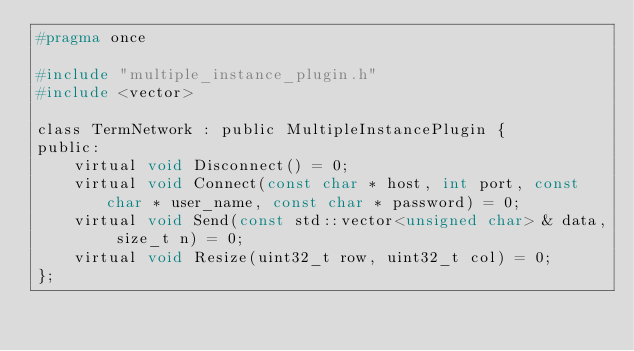<code> <loc_0><loc_0><loc_500><loc_500><_C_>#pragma once

#include "multiple_instance_plugin.h"
#include <vector>

class TermNetwork : public MultipleInstancePlugin {
public:
    virtual void Disconnect() = 0;
    virtual void Connect(const char * host, int port, const char * user_name, const char * password) = 0;
    virtual void Send(const std::vector<unsigned char> & data, size_t n) = 0;
    virtual void Resize(uint32_t row, uint32_t col) = 0;
};
</code> 